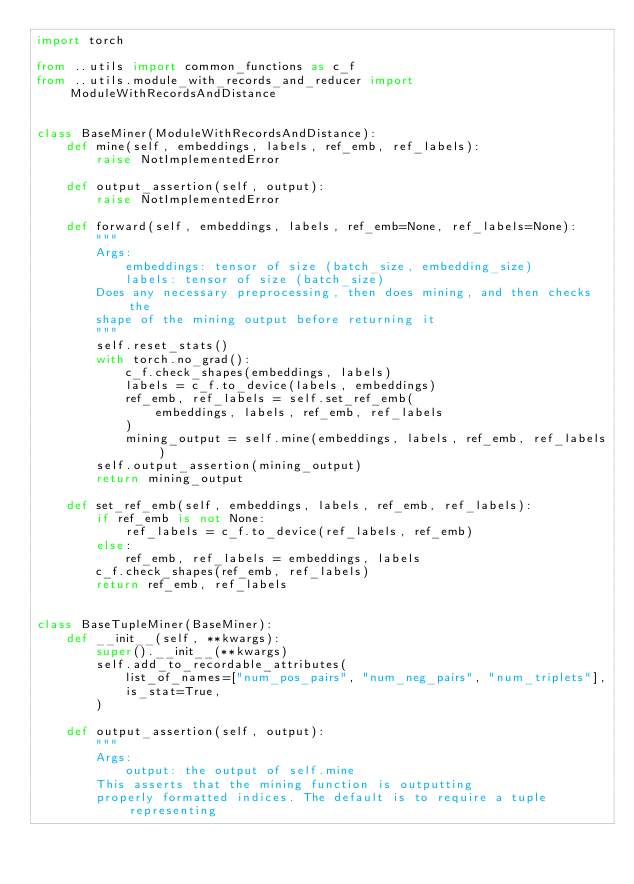Convert code to text. <code><loc_0><loc_0><loc_500><loc_500><_Python_>import torch

from ..utils import common_functions as c_f
from ..utils.module_with_records_and_reducer import ModuleWithRecordsAndDistance


class BaseMiner(ModuleWithRecordsAndDistance):
    def mine(self, embeddings, labels, ref_emb, ref_labels):
        raise NotImplementedError

    def output_assertion(self, output):
        raise NotImplementedError

    def forward(self, embeddings, labels, ref_emb=None, ref_labels=None):
        """
        Args:
            embeddings: tensor of size (batch_size, embedding_size)
            labels: tensor of size (batch_size)
        Does any necessary preprocessing, then does mining, and then checks the
        shape of the mining output before returning it
        """
        self.reset_stats()
        with torch.no_grad():
            c_f.check_shapes(embeddings, labels)
            labels = c_f.to_device(labels, embeddings)
            ref_emb, ref_labels = self.set_ref_emb(
                embeddings, labels, ref_emb, ref_labels
            )
            mining_output = self.mine(embeddings, labels, ref_emb, ref_labels)
        self.output_assertion(mining_output)
        return mining_output

    def set_ref_emb(self, embeddings, labels, ref_emb, ref_labels):
        if ref_emb is not None:
            ref_labels = c_f.to_device(ref_labels, ref_emb)
        else:
            ref_emb, ref_labels = embeddings, labels
        c_f.check_shapes(ref_emb, ref_labels)
        return ref_emb, ref_labels


class BaseTupleMiner(BaseMiner):
    def __init__(self, **kwargs):
        super().__init__(**kwargs)
        self.add_to_recordable_attributes(
            list_of_names=["num_pos_pairs", "num_neg_pairs", "num_triplets"],
            is_stat=True,
        )

    def output_assertion(self, output):
        """
        Args:
            output: the output of self.mine
        This asserts that the mining function is outputting
        properly formatted indices. The default is to require a tuple representing</code> 